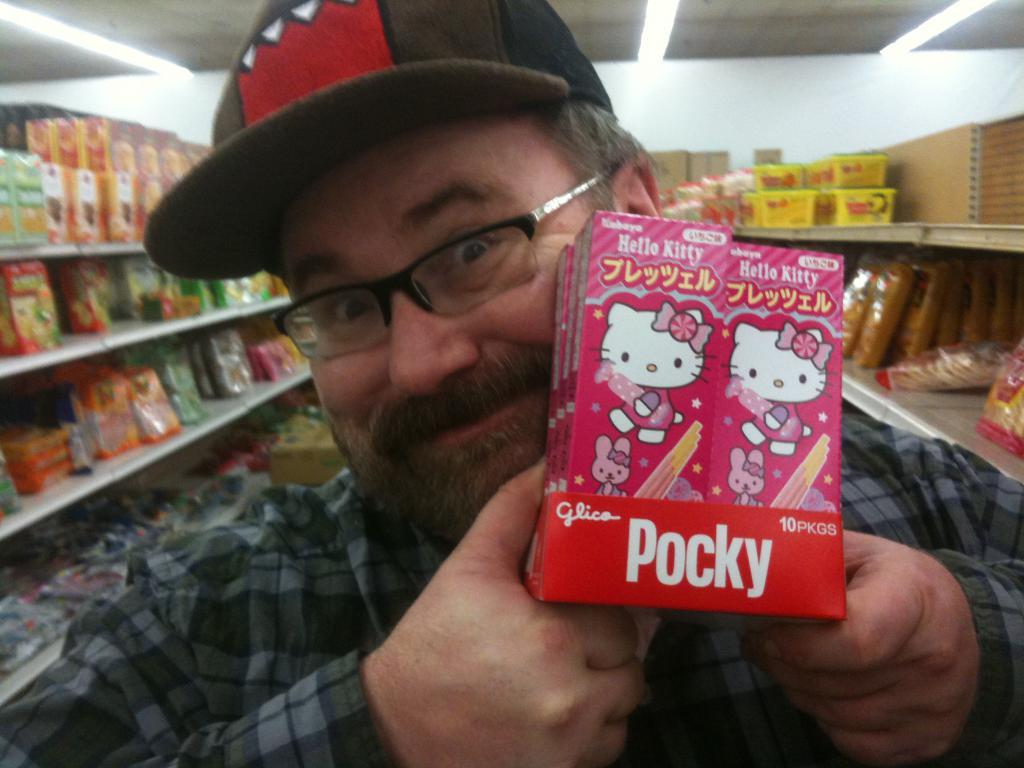Who is present in the image? There is a man in the image. What is the man wearing on his head? The man is wearing a cap. What accessory is the man wearing on his face? The man is wearing glasses. What is the man holding in his hands? The man is holding packets. What can be seen on the racks in the background? There are more packets on racks in the background. What type of lighting is present in the image? There are lights on the ceiling. What is the man's reaction to the cast's performance in the image? There is no cast or performance present in the image; it features a man holding packets and wearing a cap and glasses. 